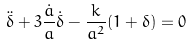<formula> <loc_0><loc_0><loc_500><loc_500>\ddot { \delta } + 3 \frac { \dot { a } } { a } \dot { \delta } - \frac { k } { a ^ { 2 } } ( 1 + \delta ) = 0</formula> 